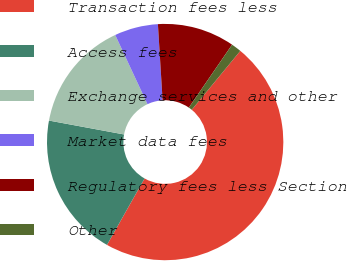Convert chart to OTSL. <chart><loc_0><loc_0><loc_500><loc_500><pie_chart><fcel>Transaction fees less<fcel>Access fees<fcel>Exchange services and other<fcel>Market data fees<fcel>Regulatory fees less Section<fcel>Other<nl><fcel>47.22%<fcel>19.72%<fcel>15.14%<fcel>5.97%<fcel>10.56%<fcel>1.39%<nl></chart> 